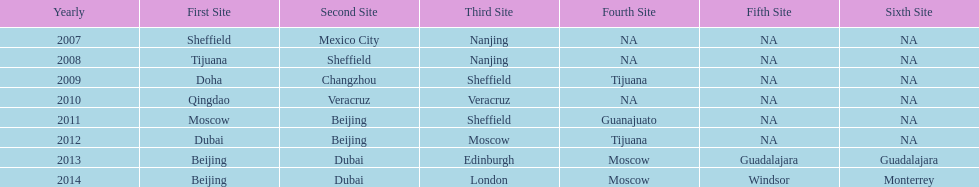Indicate a year where the second venue matched the one from 201 2012. 